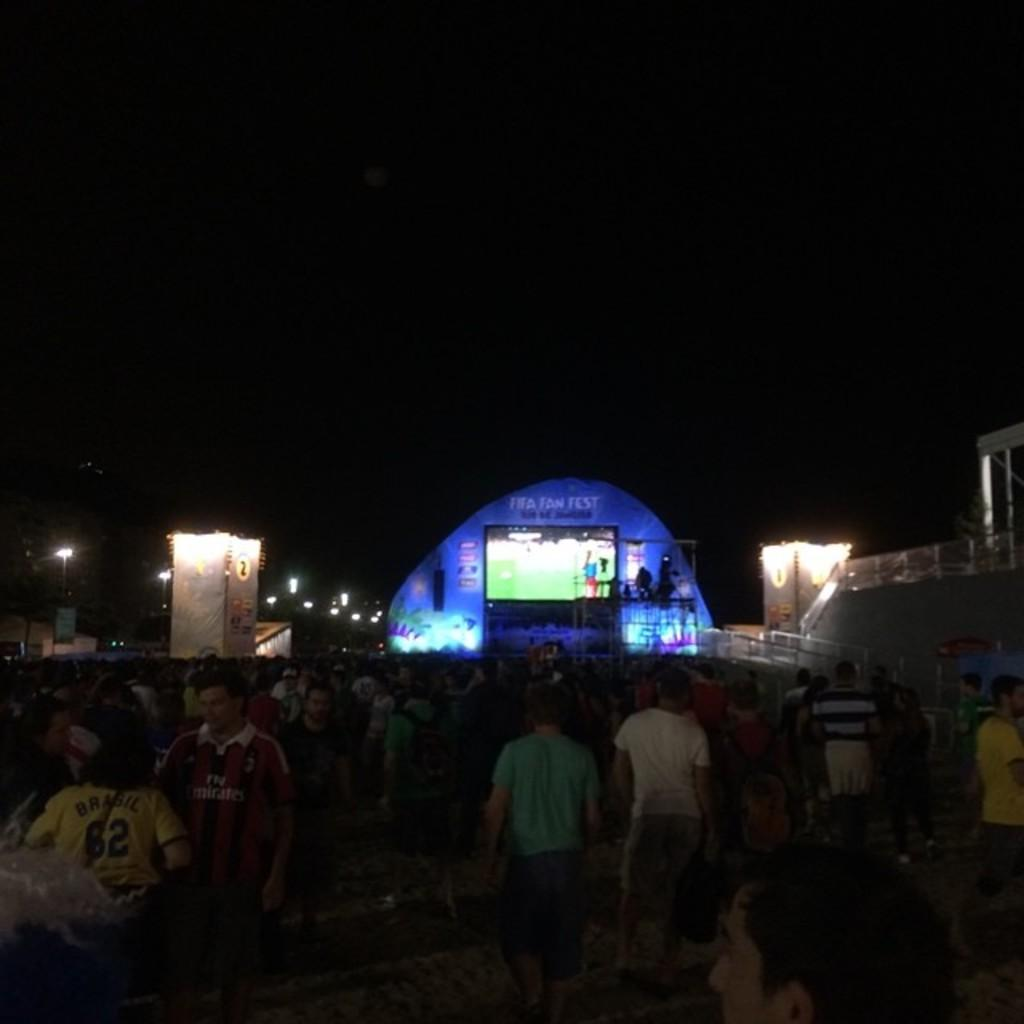How many people are in the image? There is a group of people in the image. What is the position of the people in the image? The people are on the ground. What can be seen in the background of the image? There is a screen, lights, and a fence in the background of the image. How would you describe the lighting in the image? The background is dark. What type of feather can be seen in the image? There is no feather present in the image. How many keys are being held by the group in the image? There is no mention of keys in the image; the focus is on the people and the background. 